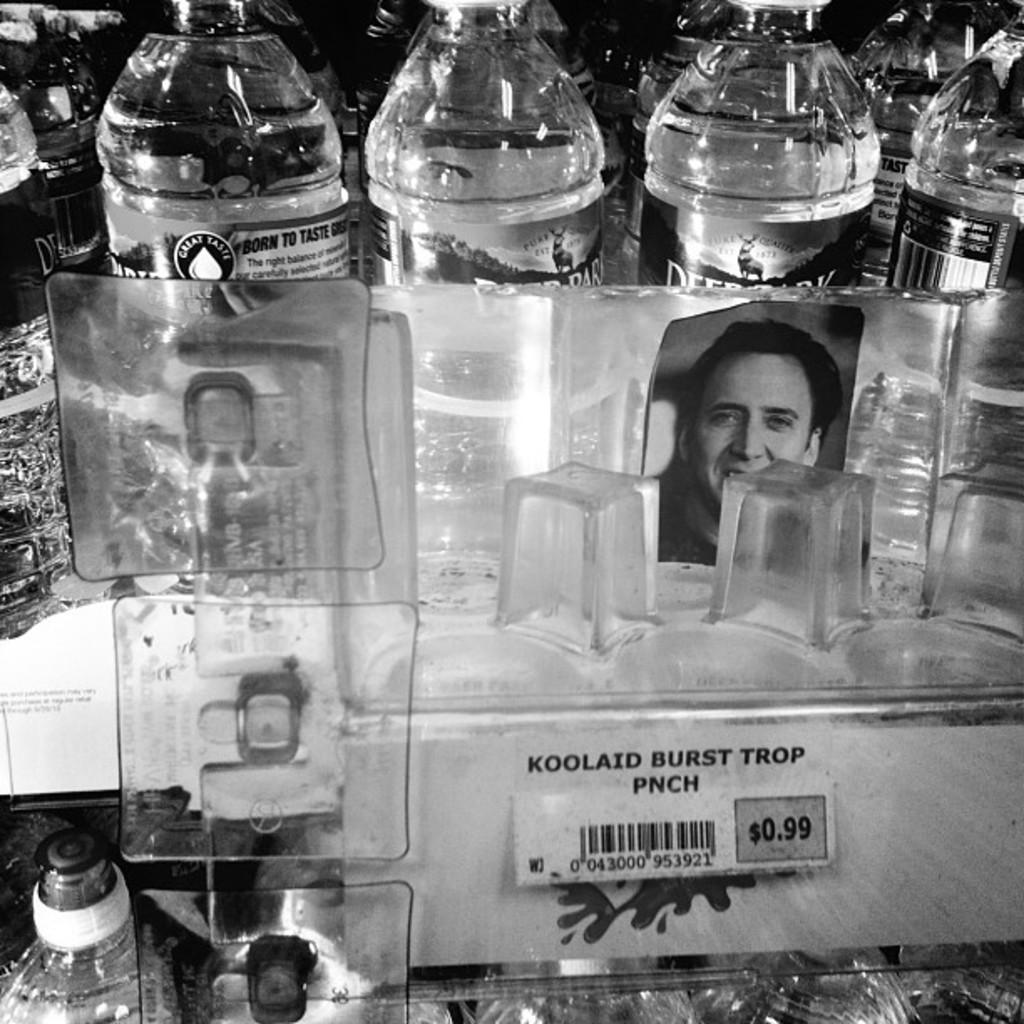What objects in the image are typically used for holding liquids? There are bottles and glasses in the image. What type of item might be used for displaying a visual representation in the image? There is a photo in the image. What type of item might be used for tracking product information in the image? There is a bar code in the image. Where is the quiver located in the image? There is no quiver present in the image. What type of item might be used for providing comfort and support in the image? There is no cushion present in the image. What type of item might be used for organizing and managing tasks in the image? There is no station present in the image. 